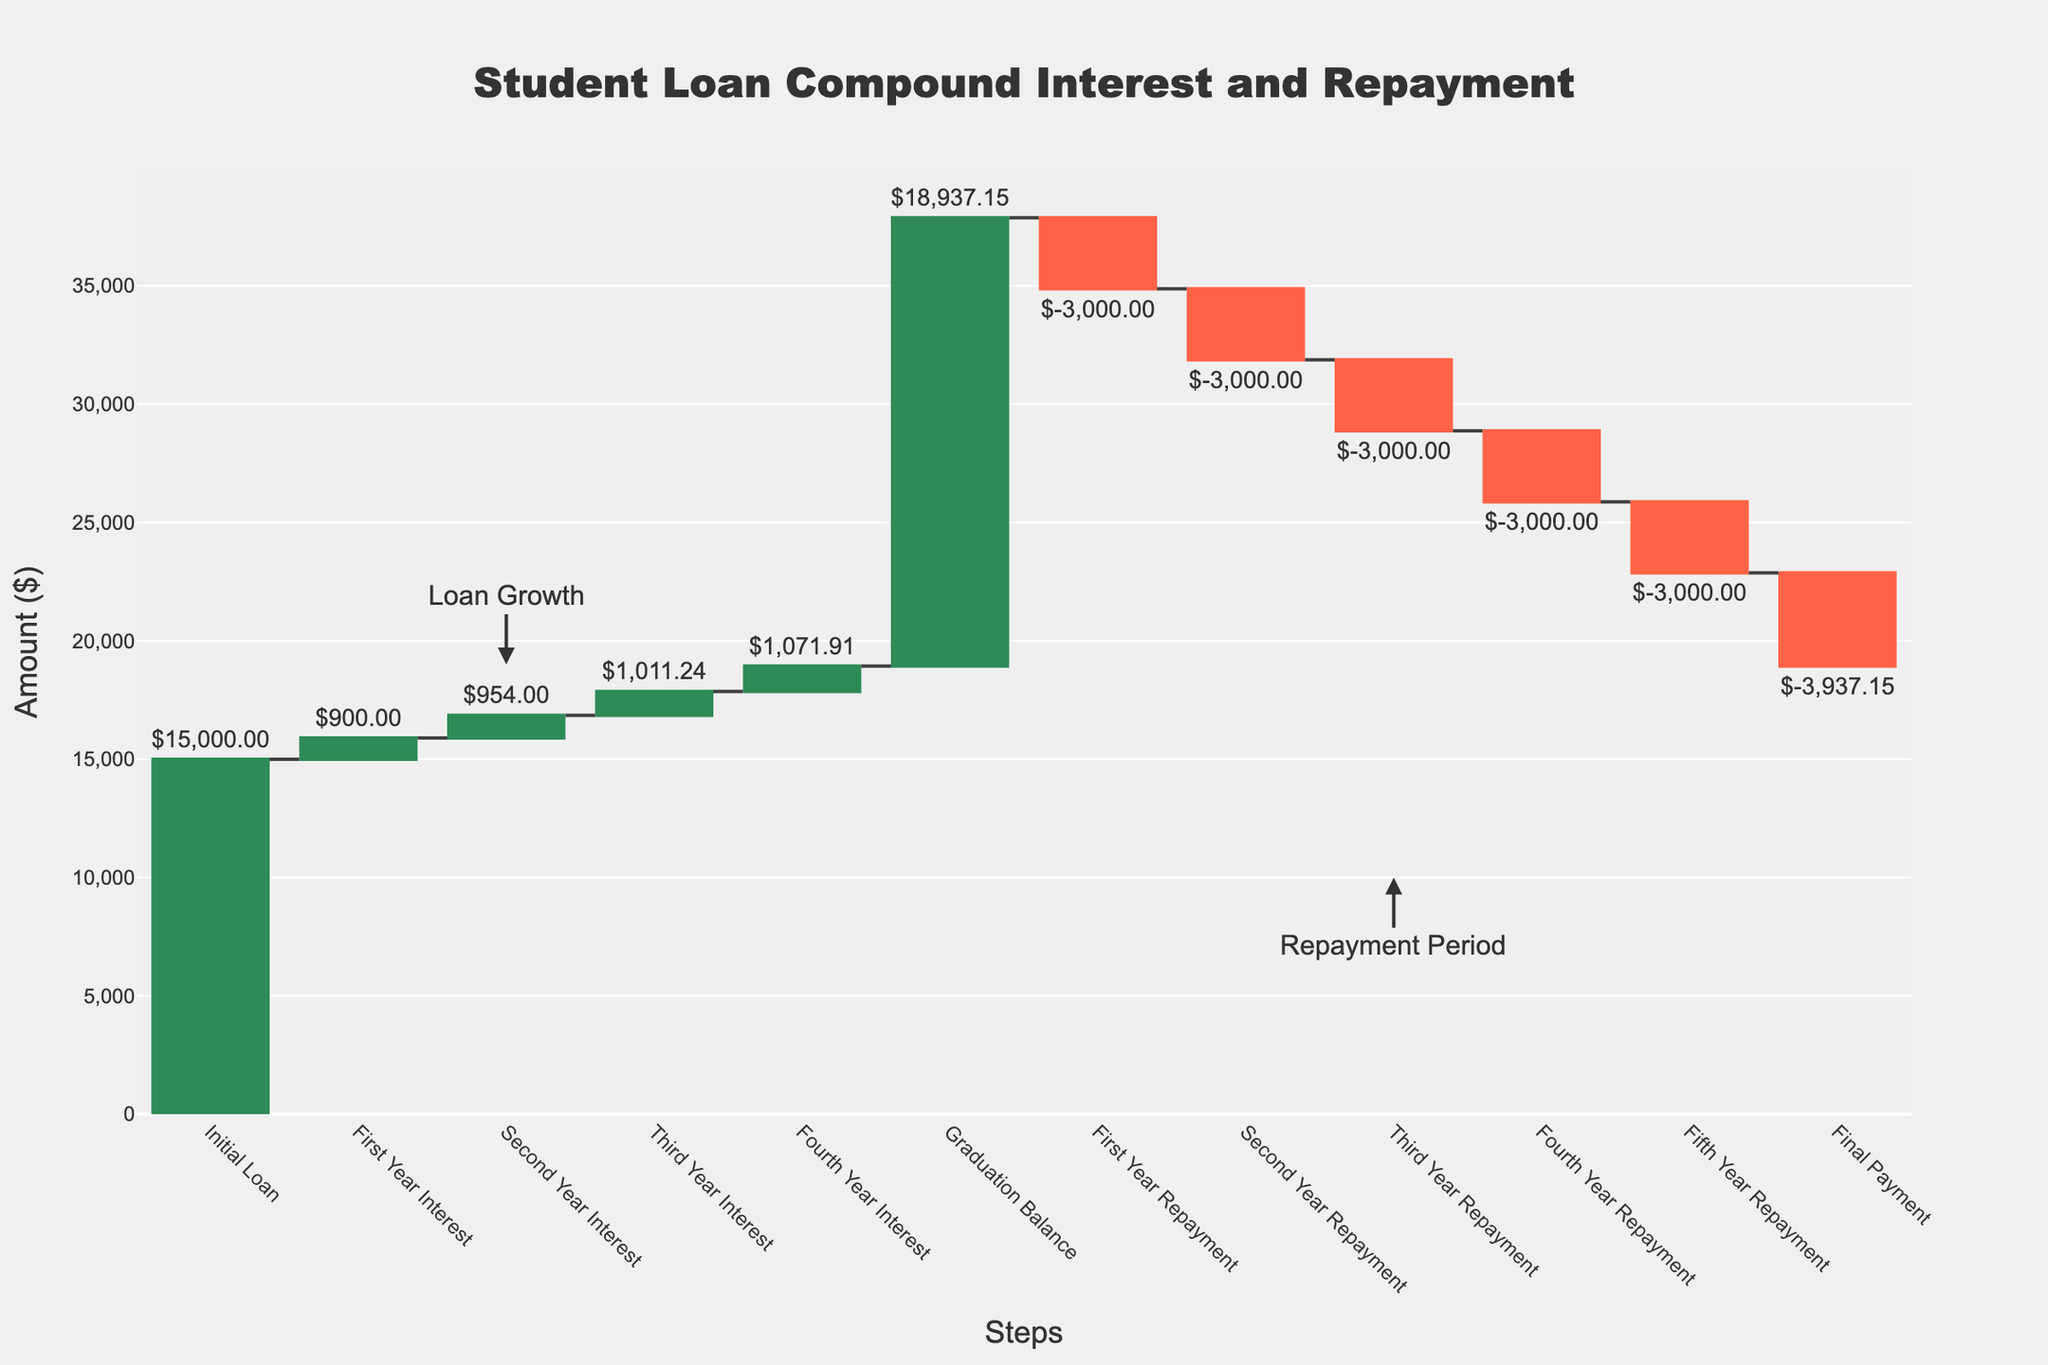What is the initial loan amount displayed on the Waterfall Chart? The initial loan amount is the starting value in the Waterfall Chart, labeled as "Initial Loan" with an amount of $15,000.
Answer: $15,000 What is the total amount added by interest over the first four years? Add the values of the interest for each year: $900 (First Year) + $954 (Second Year) + $1011.24 (Third Year) + $1071.91 (Fourth Year) = $3937.15.
Answer: $3937.15 How does the balance change after the first year of repayment? The balance after the first year of repayment is calculated by subtracting the first-year repayment from the graduation balance: $18,937.15 - $3,000 = $15,937.15.
Answer: $15,937.15 Which step has the highest amount of repayment, and what is that amount? During each repayment year (First, Second, Third, Fourth, and Fifth Year Repayment), the repayment amount is consistent: -$3,000. So each repayment is equal in amount.
Answer: $3,000 (consistent in each repayment step) What is the final payment amount, and what does it result in? The final payment amount is shown as -$3,937.15, which zeroes out the loan balance to $0.
Answer: -$3,937.15, results in $0 balance What is the net increase in loan balance from the Initial Loan to the Graduation Balance? The net increase in loan balance is calculated by subtracting the Initial Loan amount from the Graduation Balance: $18,937.15 (Graduation Balance) - $15,000 (Initial Loan) = $3,937.15.
Answer: $3,937.15 Compare the running total of the balance at the end of the second year and the amount after the second year repayment. The running total at the end of the second year is $16,854 and the amount after the second year repayment is $12,937.15.
Answer: $16,854 vs $12,937.15 Which steps in the chart are indicated by positive amounts and how many such steps are there? Positive amounts are indicated by the steps with added interest: "First Year Interest," "Second Year Interest," "Third Year Interest," and "Fourth Year Interest." There are 4 such steps.
Answer: 4 steps Describe the trend observed during the repayment period in the Waterfall Chart. During the repayment period, each year shows a consistent repayment amount of -$3,000. This steadily decreases the loan balance until it reaches zero after the final payment.
Answer: Consistent decrease by -$3,000 per year How many years does it take to completely repay the loan after graduation? The loan is fully repaid after 5 years of consistent repayments. This is indicated by the five steps labeled "First Year Repayment" to "Fifth Year Repayment" before the "Final Payment."
Answer: 5 years 